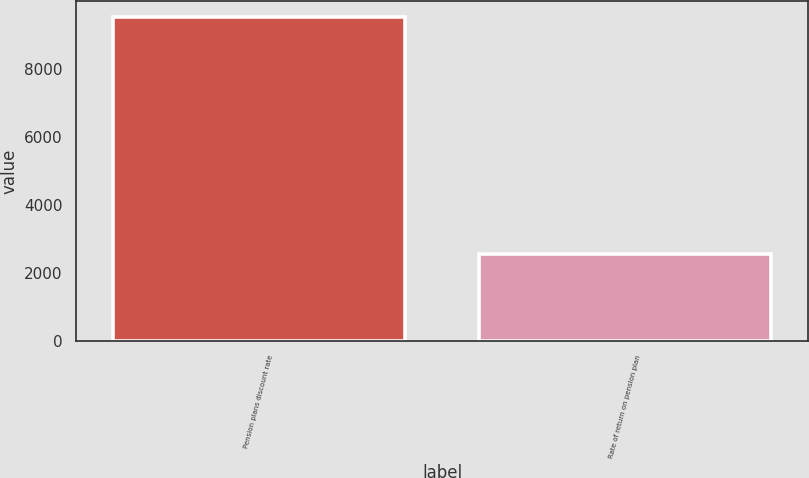Convert chart. <chart><loc_0><loc_0><loc_500><loc_500><bar_chart><fcel>Pension plans discount rate<fcel>Rate of return on pension plan<nl><fcel>9511<fcel>2563<nl></chart> 